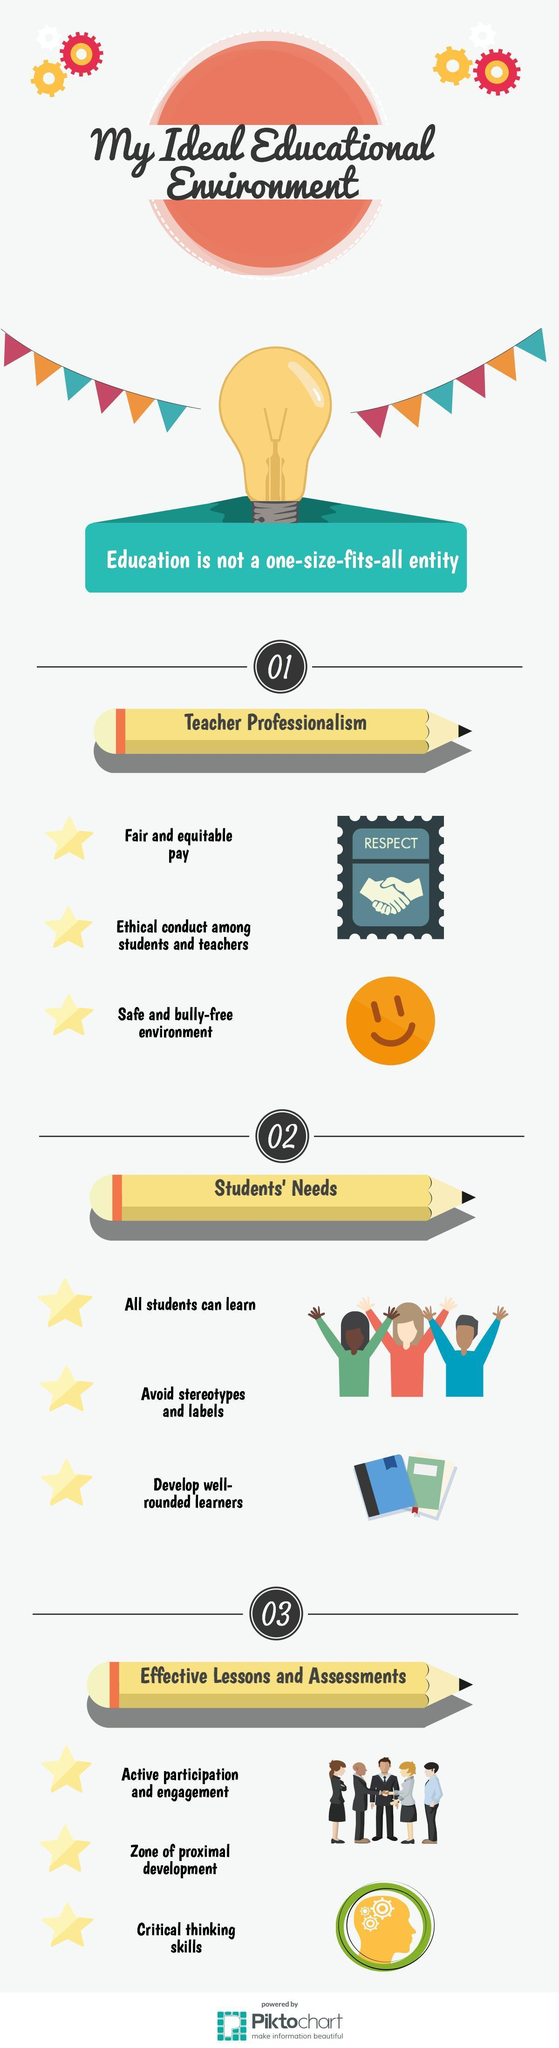What should both students and teachers do promote to ethical conduct amongst themselves?
Answer the question with a short phrase. Respect 